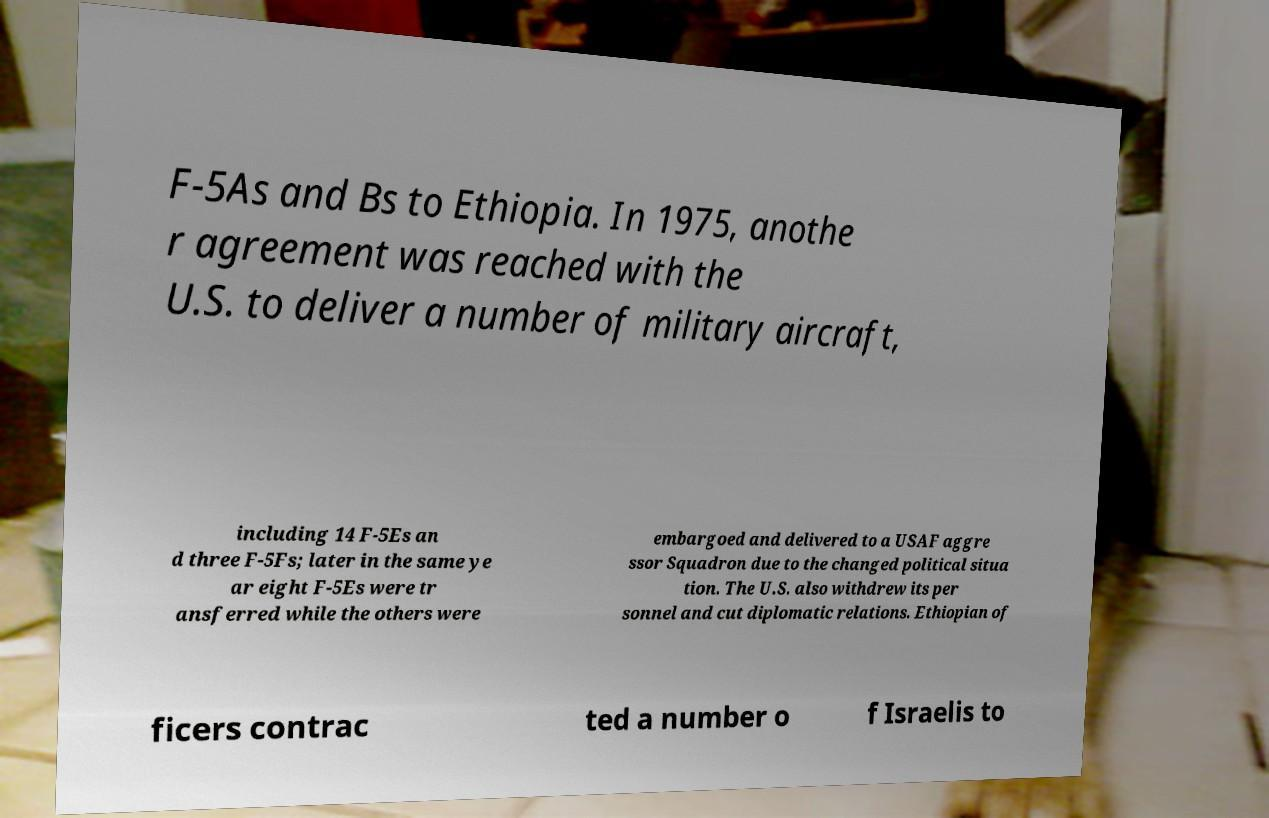For documentation purposes, I need the text within this image transcribed. Could you provide that? F-5As and Bs to Ethiopia. In 1975, anothe r agreement was reached with the U.S. to deliver a number of military aircraft, including 14 F-5Es an d three F-5Fs; later in the same ye ar eight F-5Es were tr ansferred while the others were embargoed and delivered to a USAF aggre ssor Squadron due to the changed political situa tion. The U.S. also withdrew its per sonnel and cut diplomatic relations. Ethiopian of ficers contrac ted a number o f Israelis to 